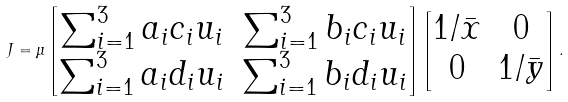<formula> <loc_0><loc_0><loc_500><loc_500>J = \mu \begin{bmatrix} \sum _ { i = 1 } ^ { 3 } a _ { i } c _ { i } u _ { i } & \sum _ { i = 1 } ^ { 3 } b _ { i } c _ { i } u _ { i } \\ \sum _ { i = 1 } ^ { 3 } a _ { i } d _ { i } u _ { i } & \sum _ { i = 1 } ^ { 3 } b _ { i } d _ { i } u _ { i } \end{bmatrix} \begin{bmatrix} 1 / \bar { x } & 0 \\ 0 & 1 / \bar { y } \end{bmatrix} .</formula> 